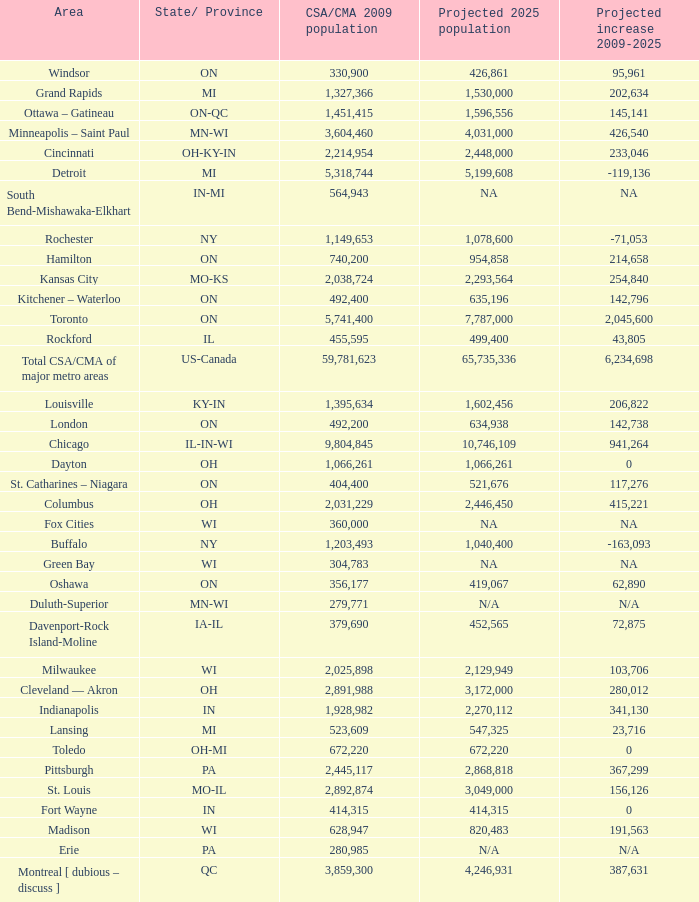What's the CSA/CMA Population in IA-IL? 379690.0. 